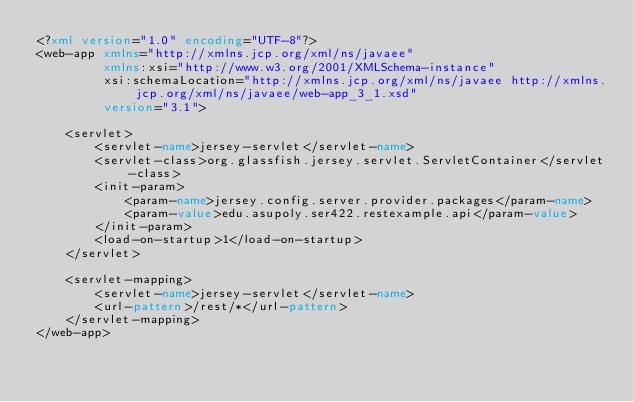Convert code to text. <code><loc_0><loc_0><loc_500><loc_500><_XML_><?xml version="1.0" encoding="UTF-8"?>
<web-app xmlns="http://xmlns.jcp.org/xml/ns/javaee"
         xmlns:xsi="http://www.w3.org/2001/XMLSchema-instance"
         xsi:schemaLocation="http://xmlns.jcp.org/xml/ns/javaee http://xmlns.jcp.org/xml/ns/javaee/web-app_3_1.xsd"
         version="3.1">

    <servlet>
        <servlet-name>jersey-servlet</servlet-name>
        <servlet-class>org.glassfish.jersey.servlet.ServletContainer</servlet-class>
        <init-param>
            <param-name>jersey.config.server.provider.packages</param-name>
            <param-value>edu.asupoly.ser422.restexample.api</param-value>
        </init-param>
        <load-on-startup>1</load-on-startup>
    </servlet>
    
    <servlet-mapping>
        <servlet-name>jersey-servlet</servlet-name>
        <url-pattern>/rest/*</url-pattern>
    </servlet-mapping>
</web-app>
</code> 